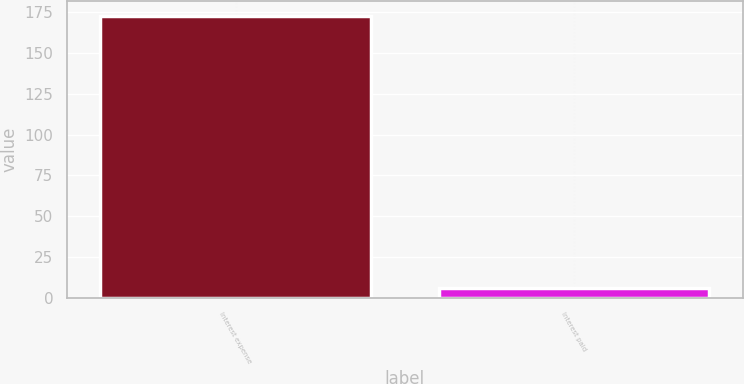Convert chart to OTSL. <chart><loc_0><loc_0><loc_500><loc_500><bar_chart><fcel>Interest expense<fcel>Interest paid<nl><fcel>173<fcel>6<nl></chart> 